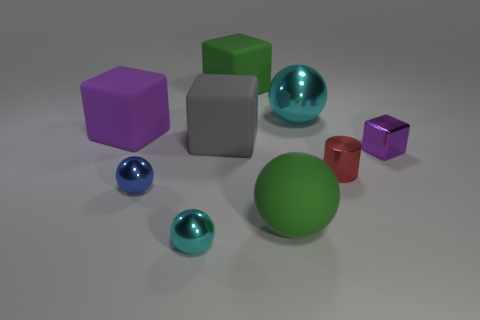Subtract 1 blocks. How many blocks are left? 3 Add 1 gray blocks. How many objects exist? 10 Subtract all cylinders. How many objects are left? 8 Add 9 green matte spheres. How many green matte spheres are left? 10 Add 1 small cylinders. How many small cylinders exist? 2 Subtract 0 red balls. How many objects are left? 9 Subtract all red metallic things. Subtract all big gray blocks. How many objects are left? 7 